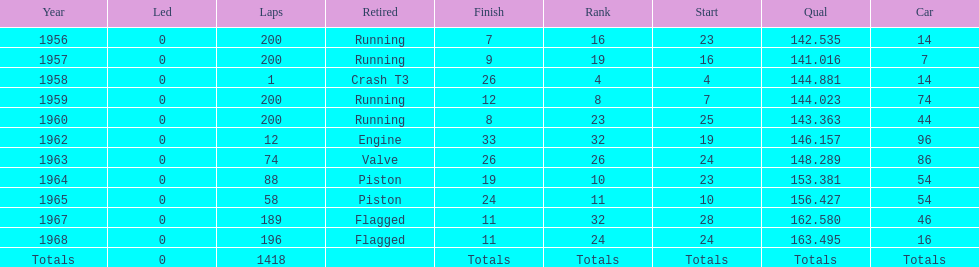Did bob veith drive more indy 500 laps in the 1950s or 1960s? 1960s. 